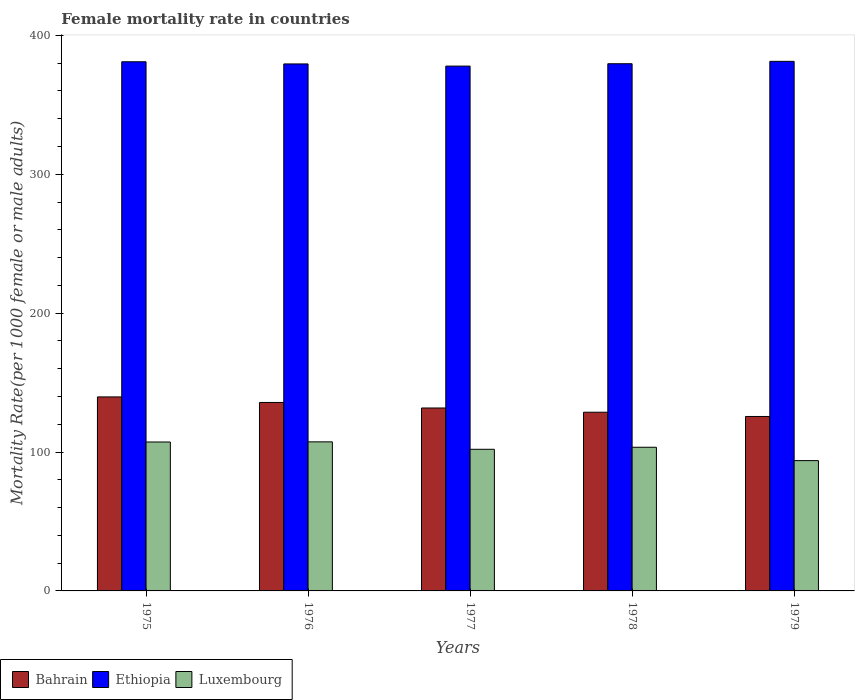How many different coloured bars are there?
Keep it short and to the point. 3. How many groups of bars are there?
Ensure brevity in your answer.  5. Are the number of bars per tick equal to the number of legend labels?
Your answer should be compact. Yes. What is the female mortality rate in Luxembourg in 1977?
Make the answer very short. 101.98. Across all years, what is the maximum female mortality rate in Bahrain?
Offer a terse response. 139.69. Across all years, what is the minimum female mortality rate in Bahrain?
Provide a succinct answer. 125.61. In which year was the female mortality rate in Bahrain maximum?
Provide a succinct answer. 1975. In which year was the female mortality rate in Bahrain minimum?
Offer a terse response. 1979. What is the total female mortality rate in Ethiopia in the graph?
Offer a very short reply. 1899.3. What is the difference between the female mortality rate in Ethiopia in 1975 and that in 1978?
Give a very brief answer. 1.42. What is the difference between the female mortality rate in Luxembourg in 1976 and the female mortality rate in Bahrain in 1979?
Keep it short and to the point. -18.26. What is the average female mortality rate in Ethiopia per year?
Your answer should be very brief. 379.86. In the year 1977, what is the difference between the female mortality rate in Ethiopia and female mortality rate in Bahrain?
Provide a succinct answer. 246.18. In how many years, is the female mortality rate in Luxembourg greater than 240?
Offer a very short reply. 0. What is the ratio of the female mortality rate in Bahrain in 1975 to that in 1977?
Your answer should be compact. 1.06. Is the female mortality rate in Luxembourg in 1975 less than that in 1978?
Give a very brief answer. No. What is the difference between the highest and the second highest female mortality rate in Bahrain?
Offer a very short reply. 3.98. What is the difference between the highest and the lowest female mortality rate in Luxembourg?
Provide a succinct answer. 13.52. What does the 2nd bar from the left in 1977 represents?
Your answer should be compact. Ethiopia. What does the 1st bar from the right in 1978 represents?
Give a very brief answer. Luxembourg. How many bars are there?
Keep it short and to the point. 15. Are all the bars in the graph horizontal?
Make the answer very short. No. What is the difference between two consecutive major ticks on the Y-axis?
Ensure brevity in your answer.  100. Does the graph contain any zero values?
Your answer should be compact. No. How many legend labels are there?
Give a very brief answer. 3. How are the legend labels stacked?
Provide a succinct answer. Horizontal. What is the title of the graph?
Keep it short and to the point. Female mortality rate in countries. What is the label or title of the X-axis?
Provide a short and direct response. Years. What is the label or title of the Y-axis?
Your answer should be very brief. Mortality Rate(per 1000 female or male adults). What is the Mortality Rate(per 1000 female or male adults) in Bahrain in 1975?
Ensure brevity in your answer.  139.69. What is the Mortality Rate(per 1000 female or male adults) in Ethiopia in 1975?
Your answer should be compact. 381.02. What is the Mortality Rate(per 1000 female or male adults) of Luxembourg in 1975?
Ensure brevity in your answer.  107.24. What is the Mortality Rate(per 1000 female or male adults) in Bahrain in 1976?
Your response must be concise. 135.71. What is the Mortality Rate(per 1000 female or male adults) of Ethiopia in 1976?
Ensure brevity in your answer.  379.46. What is the Mortality Rate(per 1000 female or male adults) in Luxembourg in 1976?
Ensure brevity in your answer.  107.34. What is the Mortality Rate(per 1000 female or male adults) in Bahrain in 1977?
Make the answer very short. 131.72. What is the Mortality Rate(per 1000 female or male adults) of Ethiopia in 1977?
Your answer should be very brief. 377.9. What is the Mortality Rate(per 1000 female or male adults) of Luxembourg in 1977?
Offer a very short reply. 101.98. What is the Mortality Rate(per 1000 female or male adults) in Bahrain in 1978?
Your response must be concise. 128.66. What is the Mortality Rate(per 1000 female or male adults) of Ethiopia in 1978?
Keep it short and to the point. 379.61. What is the Mortality Rate(per 1000 female or male adults) of Luxembourg in 1978?
Offer a terse response. 103.44. What is the Mortality Rate(per 1000 female or male adults) in Bahrain in 1979?
Keep it short and to the point. 125.61. What is the Mortality Rate(per 1000 female or male adults) in Ethiopia in 1979?
Keep it short and to the point. 381.32. What is the Mortality Rate(per 1000 female or male adults) of Luxembourg in 1979?
Your answer should be compact. 93.83. Across all years, what is the maximum Mortality Rate(per 1000 female or male adults) in Bahrain?
Give a very brief answer. 139.69. Across all years, what is the maximum Mortality Rate(per 1000 female or male adults) of Ethiopia?
Your answer should be very brief. 381.32. Across all years, what is the maximum Mortality Rate(per 1000 female or male adults) of Luxembourg?
Keep it short and to the point. 107.34. Across all years, what is the minimum Mortality Rate(per 1000 female or male adults) of Bahrain?
Offer a very short reply. 125.61. Across all years, what is the minimum Mortality Rate(per 1000 female or male adults) of Ethiopia?
Give a very brief answer. 377.9. Across all years, what is the minimum Mortality Rate(per 1000 female or male adults) of Luxembourg?
Your answer should be compact. 93.83. What is the total Mortality Rate(per 1000 female or male adults) in Bahrain in the graph?
Provide a short and direct response. 661.39. What is the total Mortality Rate(per 1000 female or male adults) in Ethiopia in the graph?
Offer a very short reply. 1899.31. What is the total Mortality Rate(per 1000 female or male adults) in Luxembourg in the graph?
Give a very brief answer. 513.82. What is the difference between the Mortality Rate(per 1000 female or male adults) in Bahrain in 1975 and that in 1976?
Give a very brief answer. 3.98. What is the difference between the Mortality Rate(per 1000 female or male adults) of Ethiopia in 1975 and that in 1976?
Your answer should be compact. 1.56. What is the difference between the Mortality Rate(per 1000 female or male adults) in Luxembourg in 1975 and that in 1976?
Your answer should be very brief. -0.1. What is the difference between the Mortality Rate(per 1000 female or male adults) of Bahrain in 1975 and that in 1977?
Keep it short and to the point. 7.97. What is the difference between the Mortality Rate(per 1000 female or male adults) in Ethiopia in 1975 and that in 1977?
Offer a very short reply. 3.12. What is the difference between the Mortality Rate(per 1000 female or male adults) of Luxembourg in 1975 and that in 1977?
Offer a terse response. 5.26. What is the difference between the Mortality Rate(per 1000 female or male adults) in Bahrain in 1975 and that in 1978?
Offer a terse response. 11.03. What is the difference between the Mortality Rate(per 1000 female or male adults) in Ethiopia in 1975 and that in 1978?
Keep it short and to the point. 1.42. What is the difference between the Mortality Rate(per 1000 female or male adults) in Luxembourg in 1975 and that in 1978?
Give a very brief answer. 3.79. What is the difference between the Mortality Rate(per 1000 female or male adults) in Bahrain in 1975 and that in 1979?
Your answer should be compact. 14.08. What is the difference between the Mortality Rate(per 1000 female or male adults) of Ethiopia in 1975 and that in 1979?
Offer a terse response. -0.29. What is the difference between the Mortality Rate(per 1000 female or male adults) in Luxembourg in 1975 and that in 1979?
Your answer should be compact. 13.41. What is the difference between the Mortality Rate(per 1000 female or male adults) in Bahrain in 1976 and that in 1977?
Offer a terse response. 3.98. What is the difference between the Mortality Rate(per 1000 female or male adults) in Ethiopia in 1976 and that in 1977?
Give a very brief answer. 1.56. What is the difference between the Mortality Rate(per 1000 female or male adults) in Luxembourg in 1976 and that in 1977?
Ensure brevity in your answer.  5.36. What is the difference between the Mortality Rate(per 1000 female or male adults) in Bahrain in 1976 and that in 1978?
Keep it short and to the point. 7.04. What is the difference between the Mortality Rate(per 1000 female or male adults) of Ethiopia in 1976 and that in 1978?
Give a very brief answer. -0.15. What is the difference between the Mortality Rate(per 1000 female or male adults) in Luxembourg in 1976 and that in 1978?
Your response must be concise. 3.9. What is the difference between the Mortality Rate(per 1000 female or male adults) of Bahrain in 1976 and that in 1979?
Ensure brevity in your answer.  10.1. What is the difference between the Mortality Rate(per 1000 female or male adults) of Ethiopia in 1976 and that in 1979?
Provide a succinct answer. -1.86. What is the difference between the Mortality Rate(per 1000 female or male adults) of Luxembourg in 1976 and that in 1979?
Your response must be concise. 13.52. What is the difference between the Mortality Rate(per 1000 female or male adults) in Bahrain in 1977 and that in 1978?
Provide a short and direct response. 3.06. What is the difference between the Mortality Rate(per 1000 female or male adults) of Ethiopia in 1977 and that in 1978?
Make the answer very short. -1.71. What is the difference between the Mortality Rate(per 1000 female or male adults) of Luxembourg in 1977 and that in 1978?
Keep it short and to the point. -1.46. What is the difference between the Mortality Rate(per 1000 female or male adults) of Bahrain in 1977 and that in 1979?
Keep it short and to the point. 6.12. What is the difference between the Mortality Rate(per 1000 female or male adults) in Ethiopia in 1977 and that in 1979?
Make the answer very short. -3.42. What is the difference between the Mortality Rate(per 1000 female or male adults) of Luxembourg in 1977 and that in 1979?
Your answer should be very brief. 8.15. What is the difference between the Mortality Rate(per 1000 female or male adults) in Bahrain in 1978 and that in 1979?
Provide a short and direct response. 3.06. What is the difference between the Mortality Rate(per 1000 female or male adults) in Ethiopia in 1978 and that in 1979?
Your answer should be very brief. -1.71. What is the difference between the Mortality Rate(per 1000 female or male adults) in Luxembourg in 1978 and that in 1979?
Your answer should be compact. 9.62. What is the difference between the Mortality Rate(per 1000 female or male adults) of Bahrain in 1975 and the Mortality Rate(per 1000 female or male adults) of Ethiopia in 1976?
Provide a short and direct response. -239.77. What is the difference between the Mortality Rate(per 1000 female or male adults) of Bahrain in 1975 and the Mortality Rate(per 1000 female or male adults) of Luxembourg in 1976?
Your answer should be very brief. 32.35. What is the difference between the Mortality Rate(per 1000 female or male adults) of Ethiopia in 1975 and the Mortality Rate(per 1000 female or male adults) of Luxembourg in 1976?
Make the answer very short. 273.68. What is the difference between the Mortality Rate(per 1000 female or male adults) of Bahrain in 1975 and the Mortality Rate(per 1000 female or male adults) of Ethiopia in 1977?
Provide a succinct answer. -238.21. What is the difference between the Mortality Rate(per 1000 female or male adults) in Bahrain in 1975 and the Mortality Rate(per 1000 female or male adults) in Luxembourg in 1977?
Offer a terse response. 37.71. What is the difference between the Mortality Rate(per 1000 female or male adults) in Ethiopia in 1975 and the Mortality Rate(per 1000 female or male adults) in Luxembourg in 1977?
Keep it short and to the point. 279.05. What is the difference between the Mortality Rate(per 1000 female or male adults) in Bahrain in 1975 and the Mortality Rate(per 1000 female or male adults) in Ethiopia in 1978?
Provide a short and direct response. -239.92. What is the difference between the Mortality Rate(per 1000 female or male adults) in Bahrain in 1975 and the Mortality Rate(per 1000 female or male adults) in Luxembourg in 1978?
Make the answer very short. 36.25. What is the difference between the Mortality Rate(per 1000 female or male adults) of Ethiopia in 1975 and the Mortality Rate(per 1000 female or male adults) of Luxembourg in 1978?
Provide a succinct answer. 277.58. What is the difference between the Mortality Rate(per 1000 female or male adults) in Bahrain in 1975 and the Mortality Rate(per 1000 female or male adults) in Ethiopia in 1979?
Provide a short and direct response. -241.63. What is the difference between the Mortality Rate(per 1000 female or male adults) in Bahrain in 1975 and the Mortality Rate(per 1000 female or male adults) in Luxembourg in 1979?
Offer a very short reply. 45.87. What is the difference between the Mortality Rate(per 1000 female or male adults) of Ethiopia in 1975 and the Mortality Rate(per 1000 female or male adults) of Luxembourg in 1979?
Provide a succinct answer. 287.2. What is the difference between the Mortality Rate(per 1000 female or male adults) of Bahrain in 1976 and the Mortality Rate(per 1000 female or male adults) of Ethiopia in 1977?
Your answer should be compact. -242.19. What is the difference between the Mortality Rate(per 1000 female or male adults) in Bahrain in 1976 and the Mortality Rate(per 1000 female or male adults) in Luxembourg in 1977?
Offer a terse response. 33.73. What is the difference between the Mortality Rate(per 1000 female or male adults) in Ethiopia in 1976 and the Mortality Rate(per 1000 female or male adults) in Luxembourg in 1977?
Your answer should be very brief. 277.48. What is the difference between the Mortality Rate(per 1000 female or male adults) in Bahrain in 1976 and the Mortality Rate(per 1000 female or male adults) in Ethiopia in 1978?
Make the answer very short. -243.9. What is the difference between the Mortality Rate(per 1000 female or male adults) in Bahrain in 1976 and the Mortality Rate(per 1000 female or male adults) in Luxembourg in 1978?
Your answer should be very brief. 32.26. What is the difference between the Mortality Rate(per 1000 female or male adults) in Ethiopia in 1976 and the Mortality Rate(per 1000 female or male adults) in Luxembourg in 1978?
Offer a very short reply. 276.02. What is the difference between the Mortality Rate(per 1000 female or male adults) of Bahrain in 1976 and the Mortality Rate(per 1000 female or male adults) of Ethiopia in 1979?
Keep it short and to the point. -245.61. What is the difference between the Mortality Rate(per 1000 female or male adults) of Bahrain in 1976 and the Mortality Rate(per 1000 female or male adults) of Luxembourg in 1979?
Offer a terse response. 41.88. What is the difference between the Mortality Rate(per 1000 female or male adults) in Ethiopia in 1976 and the Mortality Rate(per 1000 female or male adults) in Luxembourg in 1979?
Offer a very short reply. 285.63. What is the difference between the Mortality Rate(per 1000 female or male adults) of Bahrain in 1977 and the Mortality Rate(per 1000 female or male adults) of Ethiopia in 1978?
Ensure brevity in your answer.  -247.88. What is the difference between the Mortality Rate(per 1000 female or male adults) of Bahrain in 1977 and the Mortality Rate(per 1000 female or male adults) of Luxembourg in 1978?
Provide a short and direct response. 28.28. What is the difference between the Mortality Rate(per 1000 female or male adults) of Ethiopia in 1977 and the Mortality Rate(per 1000 female or male adults) of Luxembourg in 1978?
Your answer should be very brief. 274.46. What is the difference between the Mortality Rate(per 1000 female or male adults) of Bahrain in 1977 and the Mortality Rate(per 1000 female or male adults) of Ethiopia in 1979?
Provide a short and direct response. -249.59. What is the difference between the Mortality Rate(per 1000 female or male adults) of Bahrain in 1977 and the Mortality Rate(per 1000 female or male adults) of Luxembourg in 1979?
Ensure brevity in your answer.  37.9. What is the difference between the Mortality Rate(per 1000 female or male adults) of Ethiopia in 1977 and the Mortality Rate(per 1000 female or male adults) of Luxembourg in 1979?
Provide a succinct answer. 284.07. What is the difference between the Mortality Rate(per 1000 female or male adults) of Bahrain in 1978 and the Mortality Rate(per 1000 female or male adults) of Ethiopia in 1979?
Make the answer very short. -252.65. What is the difference between the Mortality Rate(per 1000 female or male adults) in Bahrain in 1978 and the Mortality Rate(per 1000 female or male adults) in Luxembourg in 1979?
Your response must be concise. 34.84. What is the difference between the Mortality Rate(per 1000 female or male adults) in Ethiopia in 1978 and the Mortality Rate(per 1000 female or male adults) in Luxembourg in 1979?
Give a very brief answer. 285.78. What is the average Mortality Rate(per 1000 female or male adults) in Bahrain per year?
Provide a short and direct response. 132.28. What is the average Mortality Rate(per 1000 female or male adults) in Ethiopia per year?
Offer a very short reply. 379.86. What is the average Mortality Rate(per 1000 female or male adults) of Luxembourg per year?
Keep it short and to the point. 102.76. In the year 1975, what is the difference between the Mortality Rate(per 1000 female or male adults) in Bahrain and Mortality Rate(per 1000 female or male adults) in Ethiopia?
Ensure brevity in your answer.  -241.33. In the year 1975, what is the difference between the Mortality Rate(per 1000 female or male adults) in Bahrain and Mortality Rate(per 1000 female or male adults) in Luxembourg?
Make the answer very short. 32.45. In the year 1975, what is the difference between the Mortality Rate(per 1000 female or male adults) in Ethiopia and Mortality Rate(per 1000 female or male adults) in Luxembourg?
Your answer should be compact. 273.79. In the year 1976, what is the difference between the Mortality Rate(per 1000 female or male adults) in Bahrain and Mortality Rate(per 1000 female or male adults) in Ethiopia?
Offer a terse response. -243.75. In the year 1976, what is the difference between the Mortality Rate(per 1000 female or male adults) of Bahrain and Mortality Rate(per 1000 female or male adults) of Luxembourg?
Provide a succinct answer. 28.36. In the year 1976, what is the difference between the Mortality Rate(per 1000 female or male adults) of Ethiopia and Mortality Rate(per 1000 female or male adults) of Luxembourg?
Offer a very short reply. 272.12. In the year 1977, what is the difference between the Mortality Rate(per 1000 female or male adults) of Bahrain and Mortality Rate(per 1000 female or male adults) of Ethiopia?
Your answer should be compact. -246.18. In the year 1977, what is the difference between the Mortality Rate(per 1000 female or male adults) of Bahrain and Mortality Rate(per 1000 female or male adults) of Luxembourg?
Offer a very short reply. 29.75. In the year 1977, what is the difference between the Mortality Rate(per 1000 female or male adults) of Ethiopia and Mortality Rate(per 1000 female or male adults) of Luxembourg?
Offer a very short reply. 275.92. In the year 1978, what is the difference between the Mortality Rate(per 1000 female or male adults) in Bahrain and Mortality Rate(per 1000 female or male adults) in Ethiopia?
Provide a succinct answer. -250.94. In the year 1978, what is the difference between the Mortality Rate(per 1000 female or male adults) in Bahrain and Mortality Rate(per 1000 female or male adults) in Luxembourg?
Your answer should be compact. 25.22. In the year 1978, what is the difference between the Mortality Rate(per 1000 female or male adults) in Ethiopia and Mortality Rate(per 1000 female or male adults) in Luxembourg?
Your answer should be compact. 276.17. In the year 1979, what is the difference between the Mortality Rate(per 1000 female or male adults) of Bahrain and Mortality Rate(per 1000 female or male adults) of Ethiopia?
Offer a very short reply. -255.71. In the year 1979, what is the difference between the Mortality Rate(per 1000 female or male adults) in Bahrain and Mortality Rate(per 1000 female or male adults) in Luxembourg?
Offer a very short reply. 31.78. In the year 1979, what is the difference between the Mortality Rate(per 1000 female or male adults) of Ethiopia and Mortality Rate(per 1000 female or male adults) of Luxembourg?
Ensure brevity in your answer.  287.49. What is the ratio of the Mortality Rate(per 1000 female or male adults) of Bahrain in 1975 to that in 1976?
Your response must be concise. 1.03. What is the ratio of the Mortality Rate(per 1000 female or male adults) in Bahrain in 1975 to that in 1977?
Make the answer very short. 1.06. What is the ratio of the Mortality Rate(per 1000 female or male adults) in Ethiopia in 1975 to that in 1977?
Your answer should be compact. 1.01. What is the ratio of the Mortality Rate(per 1000 female or male adults) in Luxembourg in 1975 to that in 1977?
Your response must be concise. 1.05. What is the ratio of the Mortality Rate(per 1000 female or male adults) in Bahrain in 1975 to that in 1978?
Offer a very short reply. 1.09. What is the ratio of the Mortality Rate(per 1000 female or male adults) of Luxembourg in 1975 to that in 1978?
Ensure brevity in your answer.  1.04. What is the ratio of the Mortality Rate(per 1000 female or male adults) in Bahrain in 1975 to that in 1979?
Provide a short and direct response. 1.11. What is the ratio of the Mortality Rate(per 1000 female or male adults) of Ethiopia in 1975 to that in 1979?
Keep it short and to the point. 1. What is the ratio of the Mortality Rate(per 1000 female or male adults) in Bahrain in 1976 to that in 1977?
Ensure brevity in your answer.  1.03. What is the ratio of the Mortality Rate(per 1000 female or male adults) of Ethiopia in 1976 to that in 1977?
Your response must be concise. 1. What is the ratio of the Mortality Rate(per 1000 female or male adults) in Luxembourg in 1976 to that in 1977?
Ensure brevity in your answer.  1.05. What is the ratio of the Mortality Rate(per 1000 female or male adults) in Bahrain in 1976 to that in 1978?
Your answer should be compact. 1.05. What is the ratio of the Mortality Rate(per 1000 female or male adults) of Ethiopia in 1976 to that in 1978?
Your answer should be compact. 1. What is the ratio of the Mortality Rate(per 1000 female or male adults) in Luxembourg in 1976 to that in 1978?
Offer a very short reply. 1.04. What is the ratio of the Mortality Rate(per 1000 female or male adults) of Bahrain in 1976 to that in 1979?
Give a very brief answer. 1.08. What is the ratio of the Mortality Rate(per 1000 female or male adults) in Ethiopia in 1976 to that in 1979?
Offer a terse response. 1. What is the ratio of the Mortality Rate(per 1000 female or male adults) of Luxembourg in 1976 to that in 1979?
Ensure brevity in your answer.  1.14. What is the ratio of the Mortality Rate(per 1000 female or male adults) in Bahrain in 1977 to that in 1978?
Your response must be concise. 1.02. What is the ratio of the Mortality Rate(per 1000 female or male adults) of Luxembourg in 1977 to that in 1978?
Keep it short and to the point. 0.99. What is the ratio of the Mortality Rate(per 1000 female or male adults) of Bahrain in 1977 to that in 1979?
Your answer should be compact. 1.05. What is the ratio of the Mortality Rate(per 1000 female or male adults) of Luxembourg in 1977 to that in 1979?
Keep it short and to the point. 1.09. What is the ratio of the Mortality Rate(per 1000 female or male adults) of Bahrain in 1978 to that in 1979?
Your answer should be compact. 1.02. What is the ratio of the Mortality Rate(per 1000 female or male adults) in Ethiopia in 1978 to that in 1979?
Offer a very short reply. 1. What is the ratio of the Mortality Rate(per 1000 female or male adults) of Luxembourg in 1978 to that in 1979?
Provide a succinct answer. 1.1. What is the difference between the highest and the second highest Mortality Rate(per 1000 female or male adults) of Bahrain?
Your answer should be very brief. 3.98. What is the difference between the highest and the second highest Mortality Rate(per 1000 female or male adults) in Ethiopia?
Offer a very short reply. 0.29. What is the difference between the highest and the second highest Mortality Rate(per 1000 female or male adults) in Luxembourg?
Your answer should be very brief. 0.1. What is the difference between the highest and the lowest Mortality Rate(per 1000 female or male adults) of Bahrain?
Your response must be concise. 14.08. What is the difference between the highest and the lowest Mortality Rate(per 1000 female or male adults) in Ethiopia?
Provide a short and direct response. 3.42. What is the difference between the highest and the lowest Mortality Rate(per 1000 female or male adults) in Luxembourg?
Your answer should be compact. 13.52. 